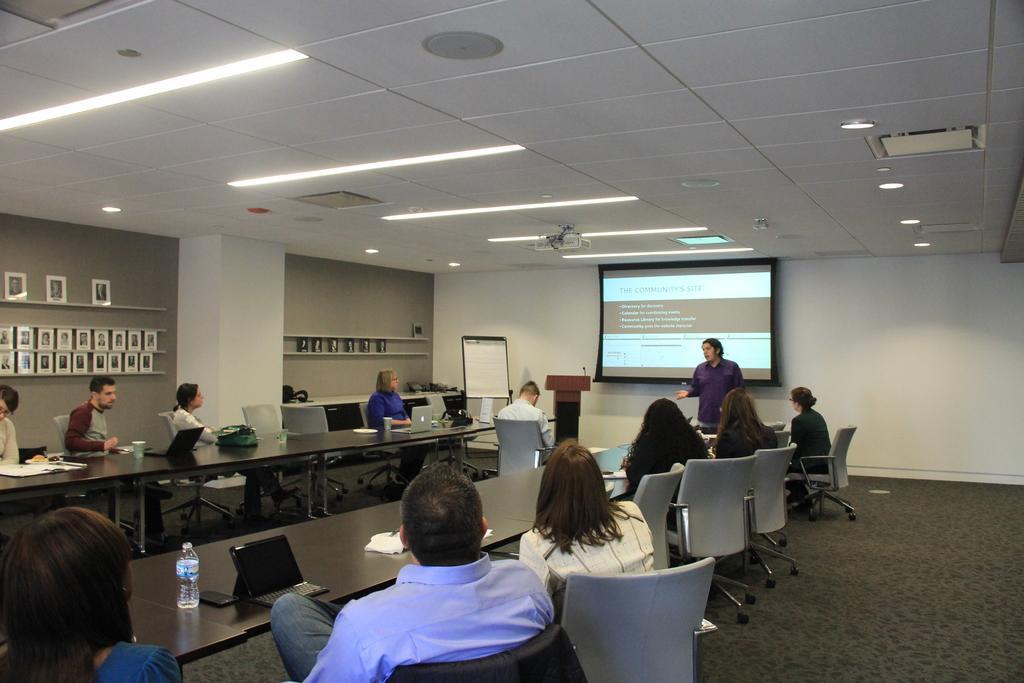Describe this image in one or two sentences. In this image there are few people sitting on the chairs and in front of them there is a table and on top of the table there are water bottles, laptops, cups and few other objects. At the back side there is a wall and a rack is attached to it. There are photo frames on the rack. At the center there is a screen and in front of the screen there is a person standing on the floor. Beside the person there is a dais and on top of it there is a mike. Beside the days there is a board. On top of the roof there are fall ceiling lights and a projector. 